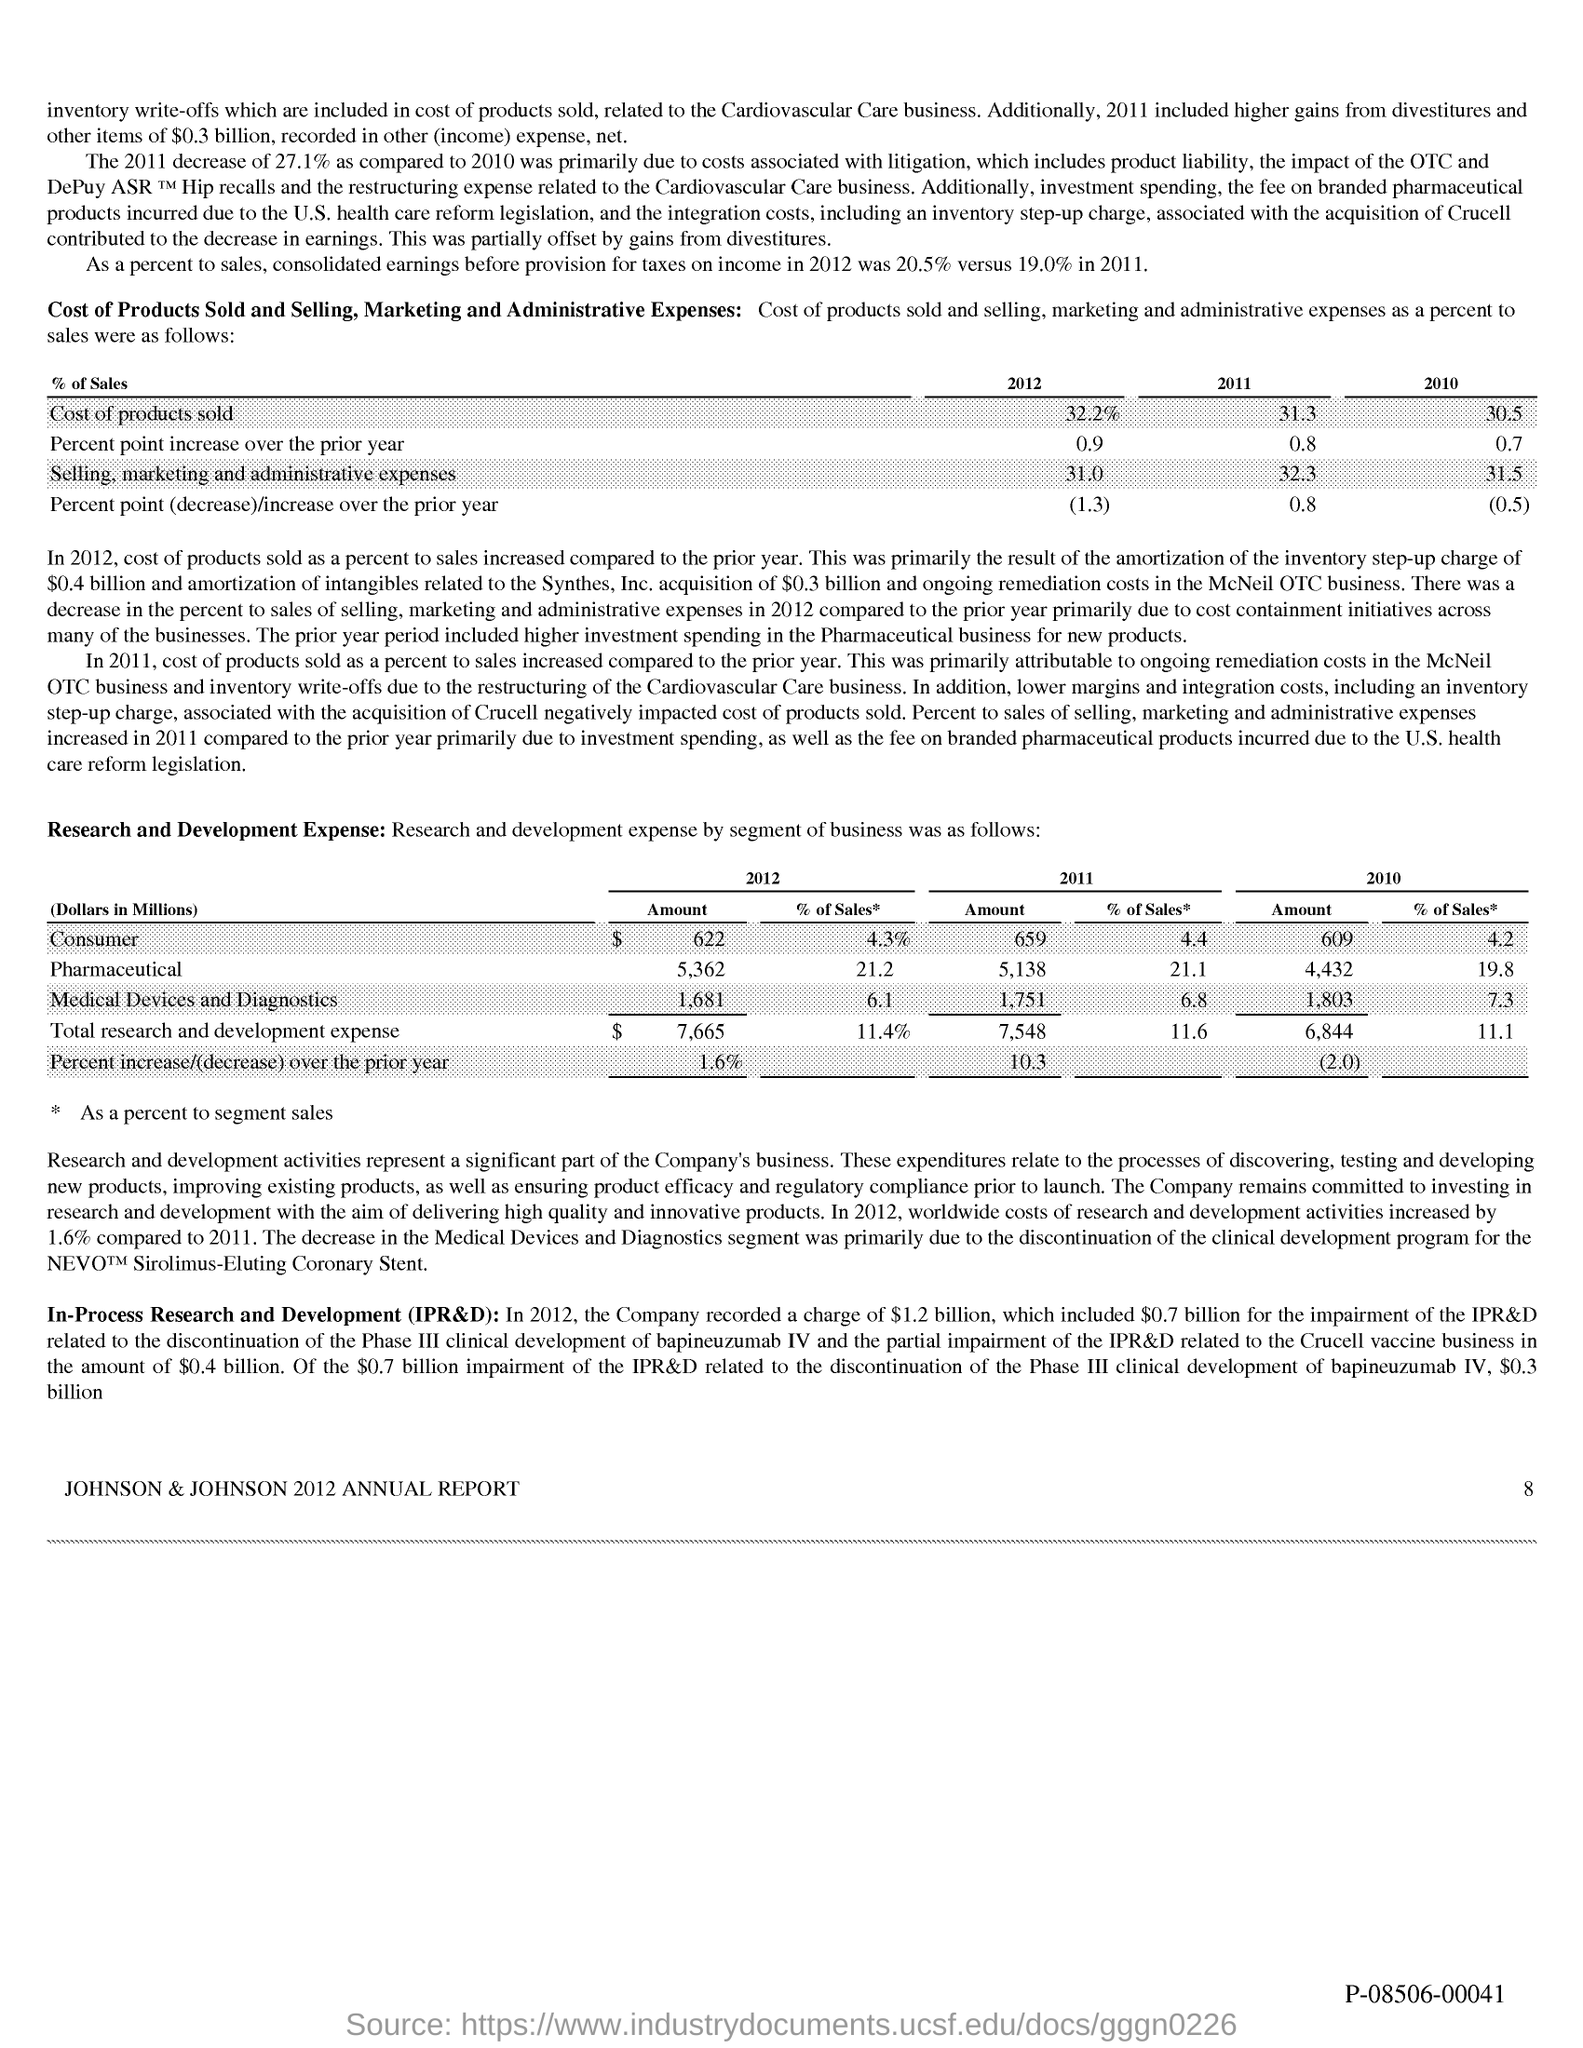Identify some key points in this picture. The title of this report is the Johnson & Johnson 2012 Annual Report. 